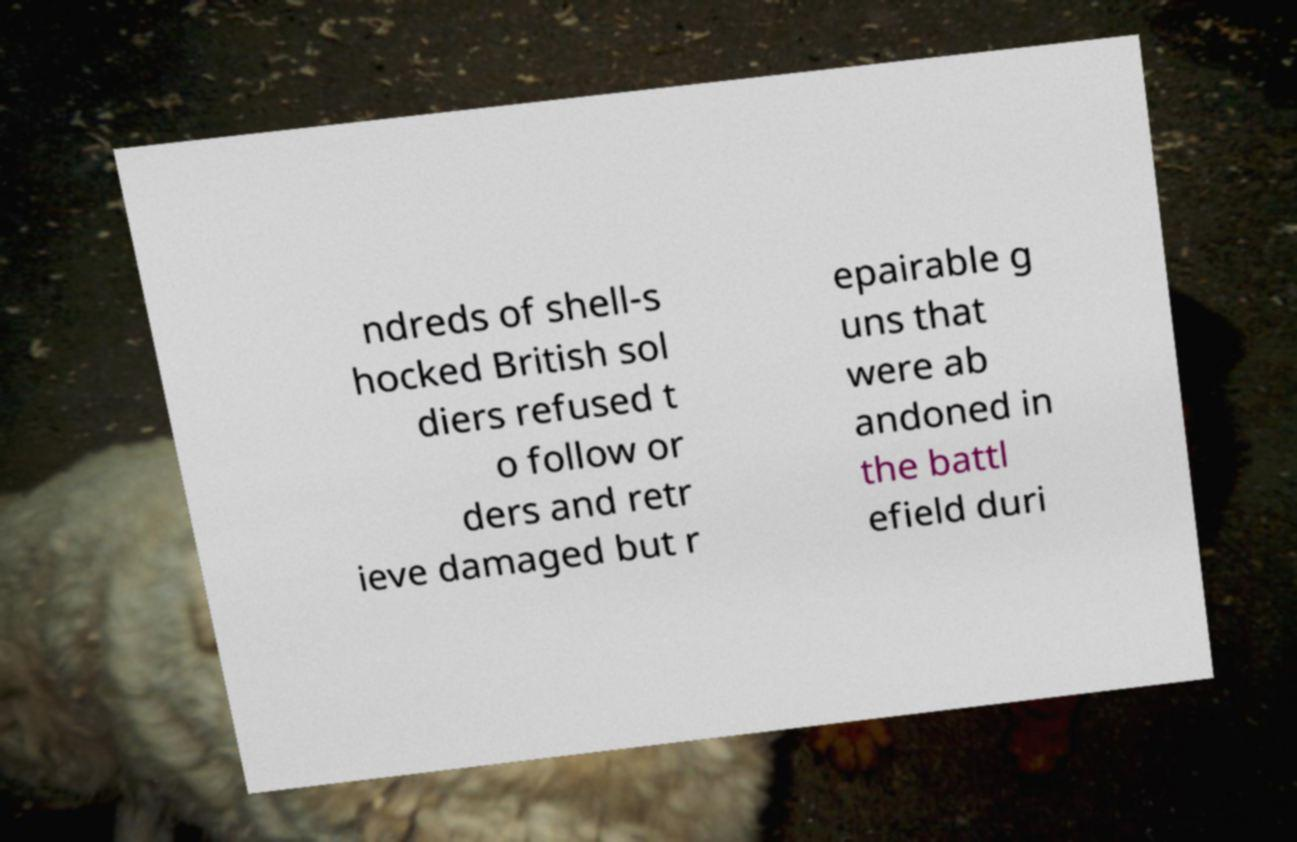Please read and relay the text visible in this image. What does it say? ndreds of shell-s hocked British sol diers refused t o follow or ders and retr ieve damaged but r epairable g uns that were ab andoned in the battl efield duri 